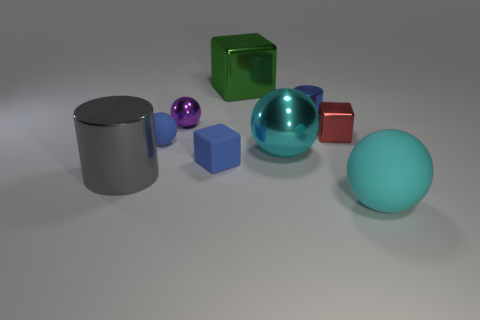Can you explain the perspective and arrangement of the objects? The objects are laid out on a flat surface and appear to be arranged randomly. The perspective is from a slightly elevated angle, looking down upon the scene. This angle provides a clear view of the top and sides of the objects, and due to the perspective, objects farther from the viewpoint look smaller, creating a sense of depth in the image. The arrangement does not suggest any particular pattern, but it offers a good study of shape, color, and material contrast. 